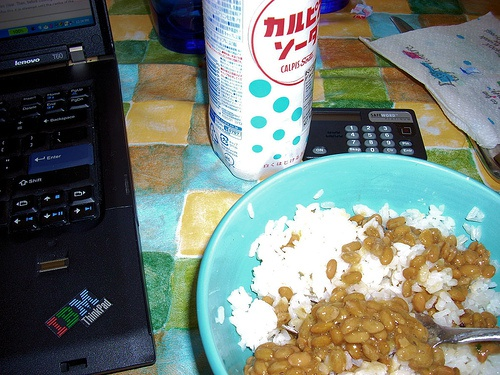Describe the objects in this image and their specific colors. I can see dining table in black, white, turquoise, lightblue, and tan tones, bowl in black, white, turquoise, olive, and lightblue tones, remote in brown, black, navy, gray, and blue tones, laptop in black, navy, gray, and blue tones, and bottle in black, white, lightblue, darkgray, and turquoise tones in this image. 